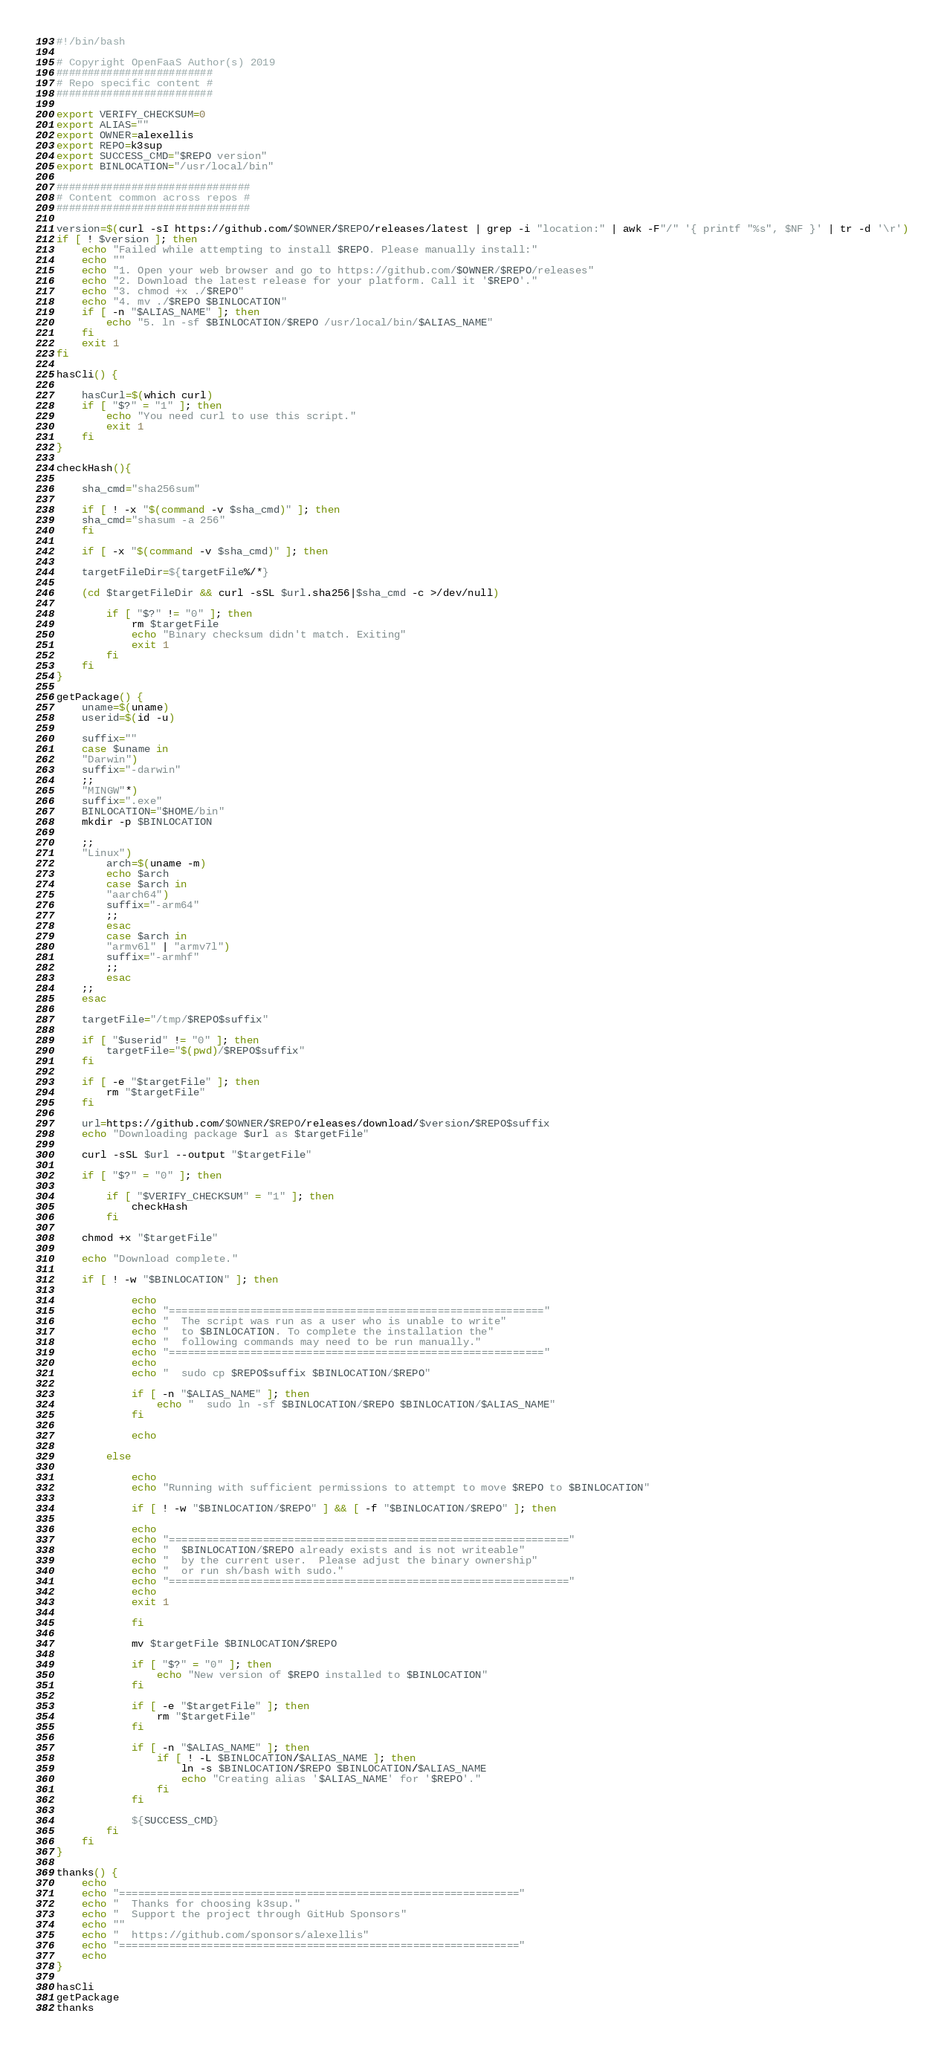Convert code to text. <code><loc_0><loc_0><loc_500><loc_500><_Bash_>#!/bin/bash

# Copyright OpenFaaS Author(s) 2019
#########################
# Repo specific content #
#########################

export VERIFY_CHECKSUM=0
export ALIAS=""
export OWNER=alexellis
export REPO=k3sup
export SUCCESS_CMD="$REPO version"
export BINLOCATION="/usr/local/bin"

###############################
# Content common across repos #
###############################

version=$(curl -sI https://github.com/$OWNER/$REPO/releases/latest | grep -i "location:" | awk -F"/" '{ printf "%s", $NF }' | tr -d '\r')
if [ ! $version ]; then
    echo "Failed while attempting to install $REPO. Please manually install:"
    echo ""
    echo "1. Open your web browser and go to https://github.com/$OWNER/$REPO/releases"
    echo "2. Download the latest release for your platform. Call it '$REPO'."
    echo "3. chmod +x ./$REPO"
    echo "4. mv ./$REPO $BINLOCATION"
    if [ -n "$ALIAS_NAME" ]; then
        echo "5. ln -sf $BINLOCATION/$REPO /usr/local/bin/$ALIAS_NAME"
    fi
    exit 1
fi

hasCli() {

    hasCurl=$(which curl)
    if [ "$?" = "1" ]; then
        echo "You need curl to use this script."
        exit 1
    fi
}

checkHash(){

    sha_cmd="sha256sum"

    if [ ! -x "$(command -v $sha_cmd)" ]; then
    sha_cmd="shasum -a 256"
    fi

    if [ -x "$(command -v $sha_cmd)" ]; then

    targetFileDir=${targetFile%/*}

    (cd $targetFileDir && curl -sSL $url.sha256|$sha_cmd -c >/dev/null)
   
        if [ "$?" != "0" ]; then
            rm $targetFile
            echo "Binary checksum didn't match. Exiting"
            exit 1
        fi   
    fi
}

getPackage() {
    uname=$(uname)
    userid=$(id -u)

    suffix=""
    case $uname in
    "Darwin")
    suffix="-darwin"
    ;;
    "MINGW"*)
    suffix=".exe"
    BINLOCATION="$HOME/bin"
    mkdir -p $BINLOCATION

    ;;
    "Linux")
        arch=$(uname -m)
        echo $arch
        case $arch in
        "aarch64")
        suffix="-arm64"
        ;;
        esac
        case $arch in
        "armv6l" | "armv7l")
        suffix="-armhf"
        ;;
        esac
    ;;
    esac

    targetFile="/tmp/$REPO$suffix"
    
    if [ "$userid" != "0" ]; then
        targetFile="$(pwd)/$REPO$suffix"
    fi

    if [ -e "$targetFile" ]; then
        rm "$targetFile"
    fi

    url=https://github.com/$OWNER/$REPO/releases/download/$version/$REPO$suffix
    echo "Downloading package $url as $targetFile"

    curl -sSL $url --output "$targetFile"

    if [ "$?" = "0" ]; then

        if [ "$VERIFY_CHECKSUM" = "1" ]; then
            checkHash
        fi

    chmod +x "$targetFile"

    echo "Download complete."
       
    if [ ! -w "$BINLOCATION" ]; then

            echo
            echo "============================================================"
            echo "  The script was run as a user who is unable to write"
            echo "  to $BINLOCATION. To complete the installation the"
            echo "  following commands may need to be run manually."
            echo "============================================================"
            echo
            echo "  sudo cp $REPO$suffix $BINLOCATION/$REPO"
            
            if [ -n "$ALIAS_NAME" ]; then
                echo "  sudo ln -sf $BINLOCATION/$REPO $BINLOCATION/$ALIAS_NAME"
            fi
            
            echo

        else

            echo
            echo "Running with sufficient permissions to attempt to move $REPO to $BINLOCATION"

            if [ ! -w "$BINLOCATION/$REPO" ] && [ -f "$BINLOCATION/$REPO" ]; then

            echo
            echo "================================================================"
            echo "  $BINLOCATION/$REPO already exists and is not writeable"
            echo "  by the current user.  Please adjust the binary ownership"
            echo "  or run sh/bash with sudo." 
            echo "================================================================"
            echo
            exit 1

            fi

            mv $targetFile $BINLOCATION/$REPO
        
            if [ "$?" = "0" ]; then
                echo "New version of $REPO installed to $BINLOCATION"
            fi

            if [ -e "$targetFile" ]; then
                rm "$targetFile"
            fi

            if [ -n "$ALIAS_NAME" ]; then
                if [ ! -L $BINLOCATION/$ALIAS_NAME ]; then
                    ln -s $BINLOCATION/$REPO $BINLOCATION/$ALIAS_NAME
                    echo "Creating alias '$ALIAS_NAME' for '$REPO'."
                fi
            fi

            ${SUCCESS_CMD}
        fi
    fi
}

thanks() {
    echo
    echo "================================================================"
    echo "  Thanks for choosing k3sup."
    echo "  Support the project through GitHub Sponsors"
    echo "" 
    echo "  https://github.com/sponsors/alexellis" 
    echo "================================================================"
    echo
}

hasCli
getPackage
thanks</code> 